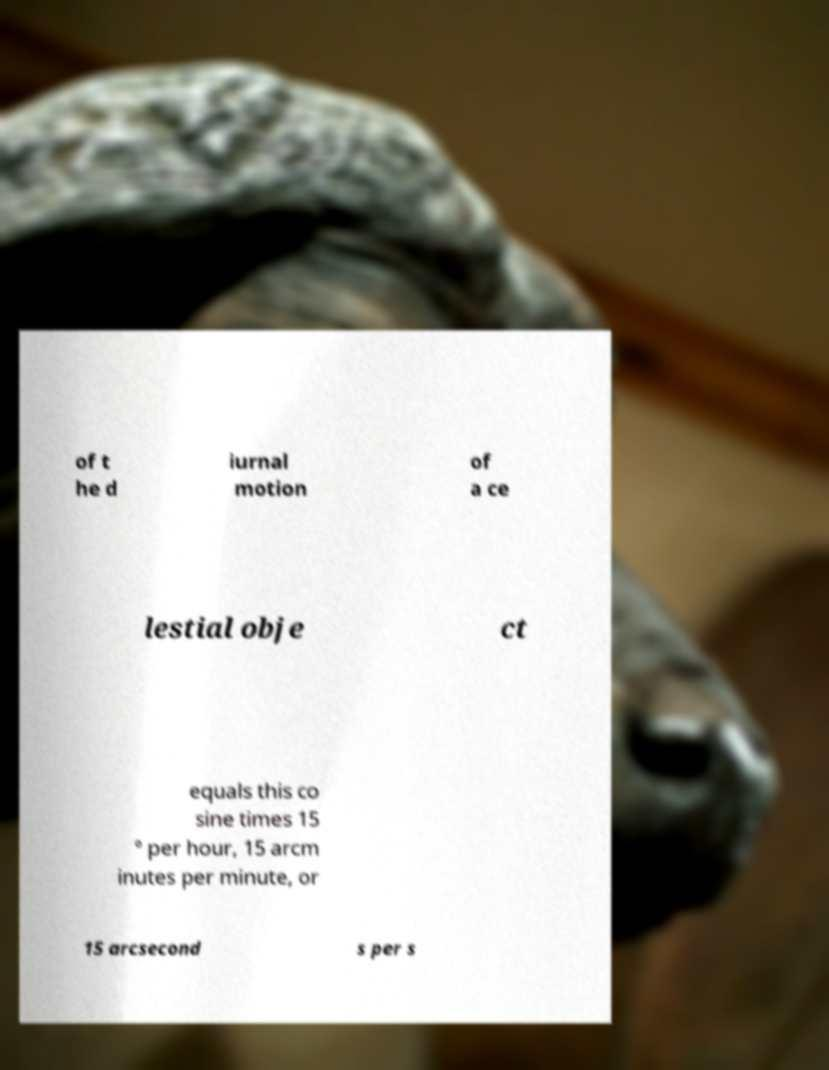There's text embedded in this image that I need extracted. Can you transcribe it verbatim? of t he d iurnal motion of a ce lestial obje ct equals this co sine times 15 ° per hour, 15 arcm inutes per minute, or 15 arcsecond s per s 